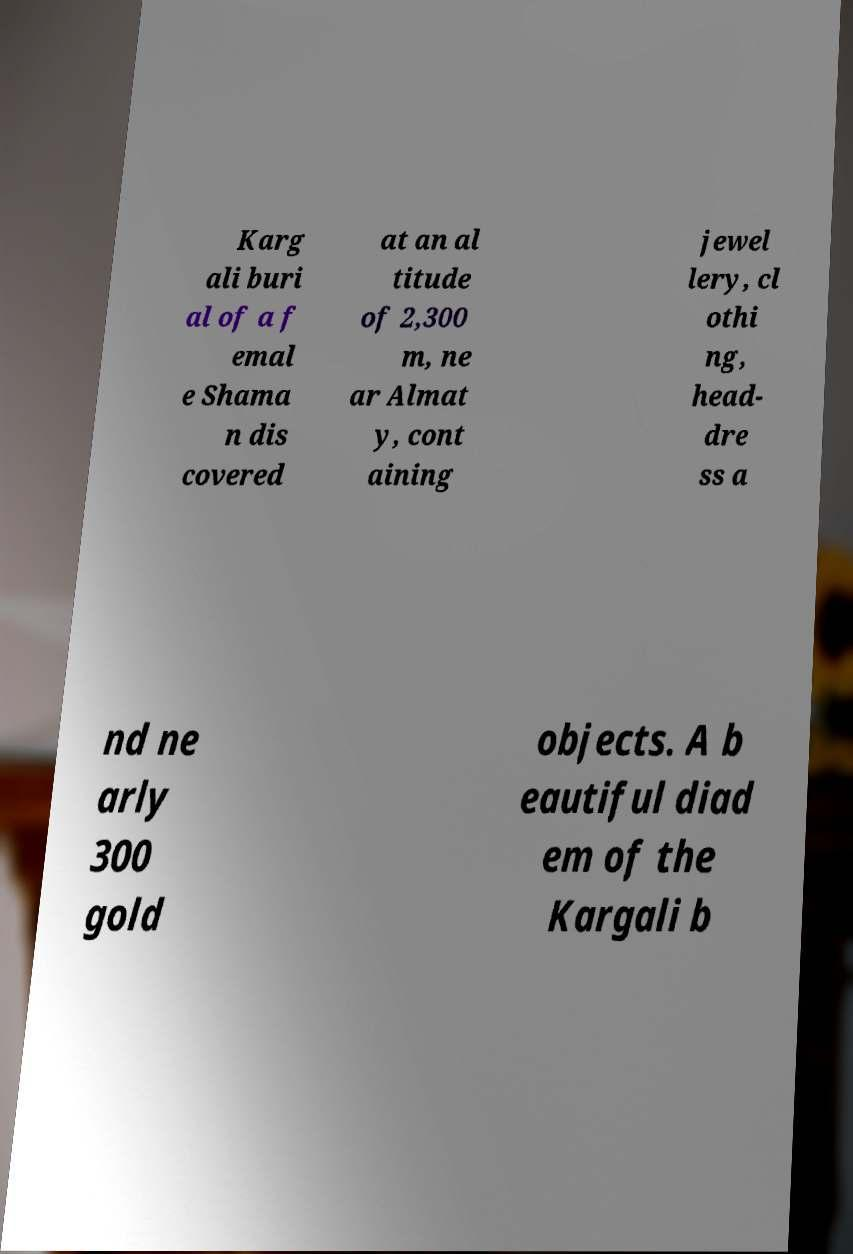Could you extract and type out the text from this image? Karg ali buri al of a f emal e Shama n dis covered at an al titude of 2,300 m, ne ar Almat y, cont aining jewel lery, cl othi ng, head- dre ss a nd ne arly 300 gold objects. A b eautiful diad em of the Kargali b 